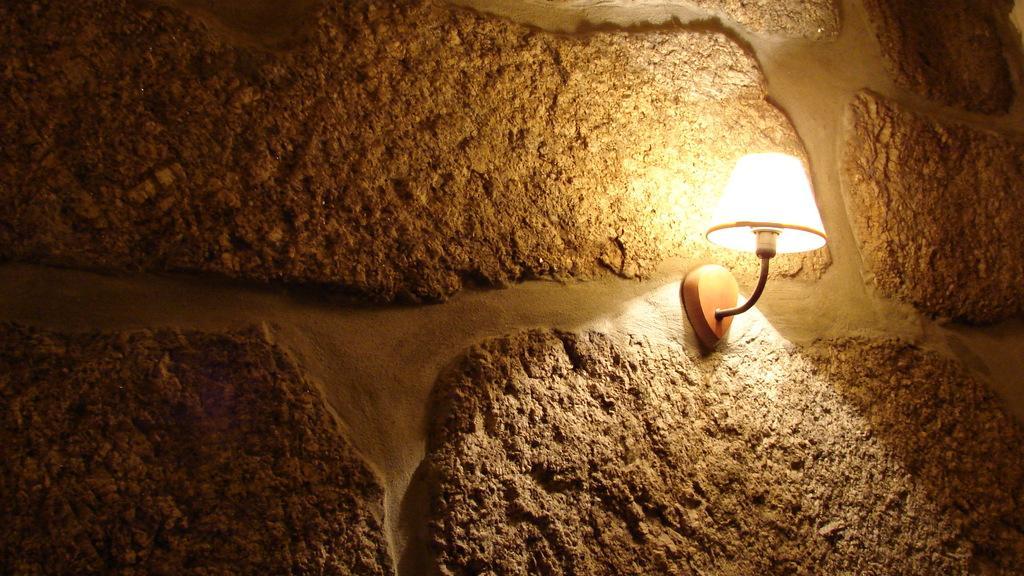In one or two sentences, can you explain what this image depicts? In this picture I can see a light on the stone wall. 